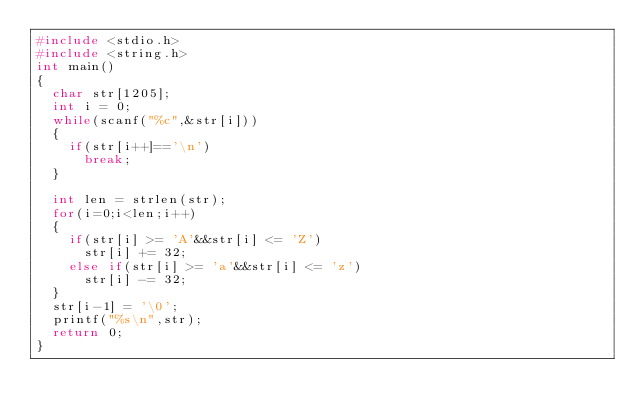Convert code to text. <code><loc_0><loc_0><loc_500><loc_500><_C_>#include <stdio.h>
#include <string.h>
int main()
{
	char str[1205];
	int i = 0;
	while(scanf("%c",&str[i]))
	{
		if(str[i++]=='\n')
			break;
	}
	
	int len = strlen(str);
	for(i=0;i<len;i++)
	{
		if(str[i] >= 'A'&&str[i] <= 'Z')
			str[i] += 32;
		else if(str[i] >= 'a'&&str[i] <= 'z')
			str[i] -= 32;
	}
	str[i-1] = '\0';
	printf("%s\n",str);
	return 0;
}
</code> 